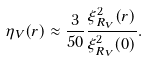<formula> <loc_0><loc_0><loc_500><loc_500>\eta _ { V } ( r ) \approx \frac { 3 } { 5 0 } \frac { \xi ^ { 2 } _ { R _ { V } } ( r ) } { \xi ^ { 2 } _ { R _ { V } } ( 0 ) } .</formula> 